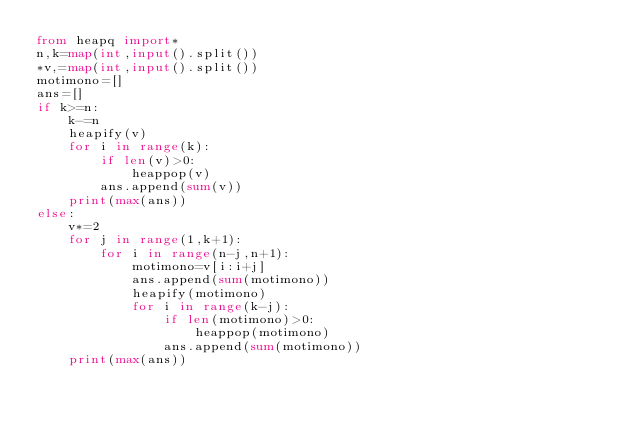<code> <loc_0><loc_0><loc_500><loc_500><_Python_>from heapq import*
n,k=map(int,input().split())
*v,=map(int,input().split())
motimono=[]
ans=[]
if k>=n:
    k-=n
    heapify(v)
    for i in range(k):
        if len(v)>0:
            heappop(v)
        ans.append(sum(v))
    print(max(ans))
else:
    v*=2
    for j in range(1,k+1):
        for i in range(n-j,n+1):
            motimono=v[i:i+j]
            ans.append(sum(motimono))
            heapify(motimono)
            for i in range(k-j):
                if len(motimono)>0:
                    heappop(motimono)
                ans.append(sum(motimono))
    print(max(ans))</code> 